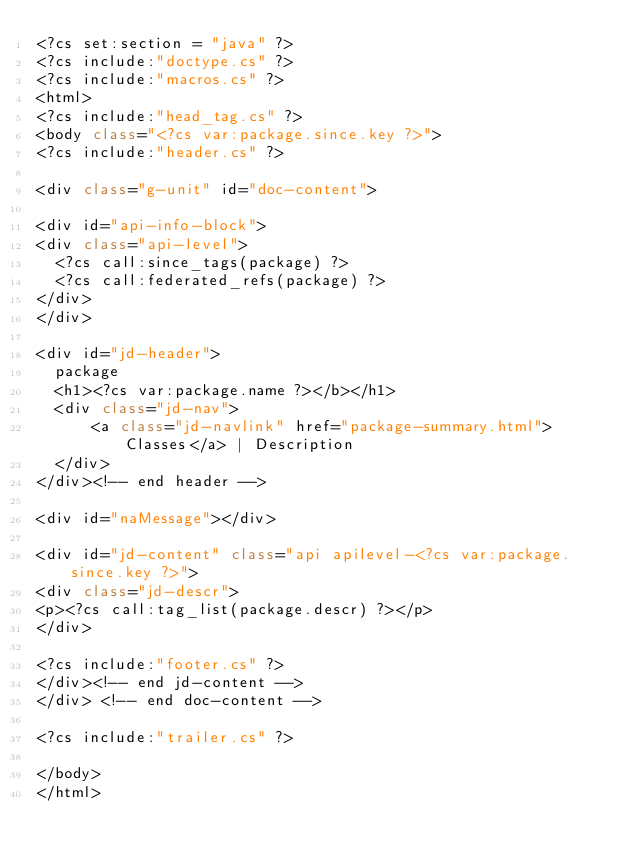Convert code to text. <code><loc_0><loc_0><loc_500><loc_500><_C#_><?cs set:section = "java" ?>
<?cs include:"doctype.cs" ?>
<?cs include:"macros.cs" ?>
<html>
<?cs include:"head_tag.cs" ?>
<body class="<?cs var:package.since.key ?>">
<?cs include:"header.cs" ?>

<div class="g-unit" id="doc-content">

<div id="api-info-block">
<div class="api-level">
  <?cs call:since_tags(package) ?>
  <?cs call:federated_refs(package) ?>
</div>
</div>

<div id="jd-header">
  package
  <h1><?cs var:package.name ?></b></h1>
  <div class="jd-nav">
      <a class="jd-navlink" href="package-summary.html">Classes</a> | Description
  </div>
</div><!-- end header -->

<div id="naMessage"></div>

<div id="jd-content" class="api apilevel-<?cs var:package.since.key ?>">
<div class="jd-descr">
<p><?cs call:tag_list(package.descr) ?></p>
</div>

<?cs include:"footer.cs" ?>
</div><!-- end jd-content -->
</div> <!-- end doc-content -->

<?cs include:"trailer.cs" ?>

</body>
</html>
</code> 